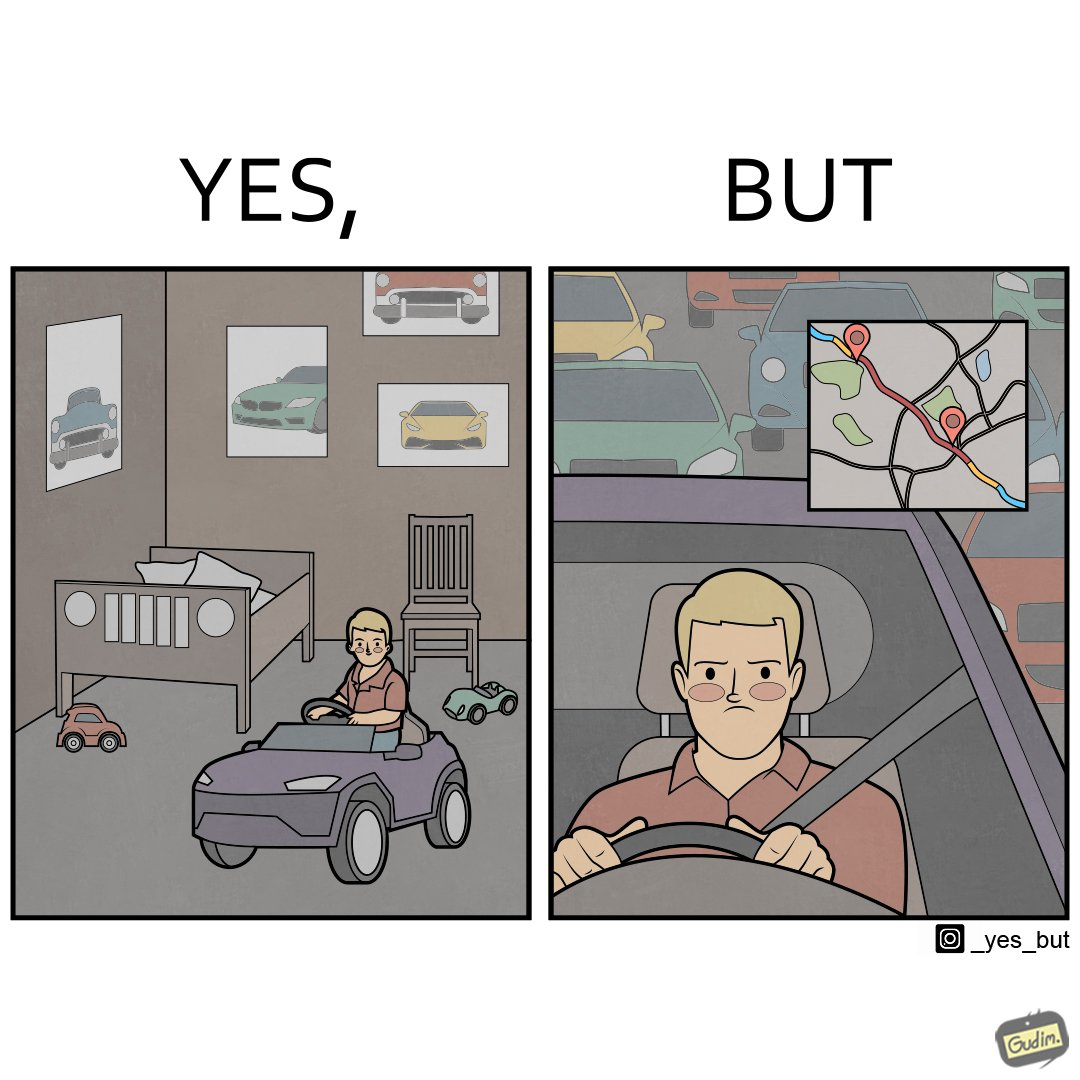What is the satirical meaning behind this image? The image is funny beaucse while the person as a child enjoyed being around cars, had various small toy cars and even rode a bigger toy car, as as grown up he does not enjoy being in a car during a traffic jam while he is driving . 